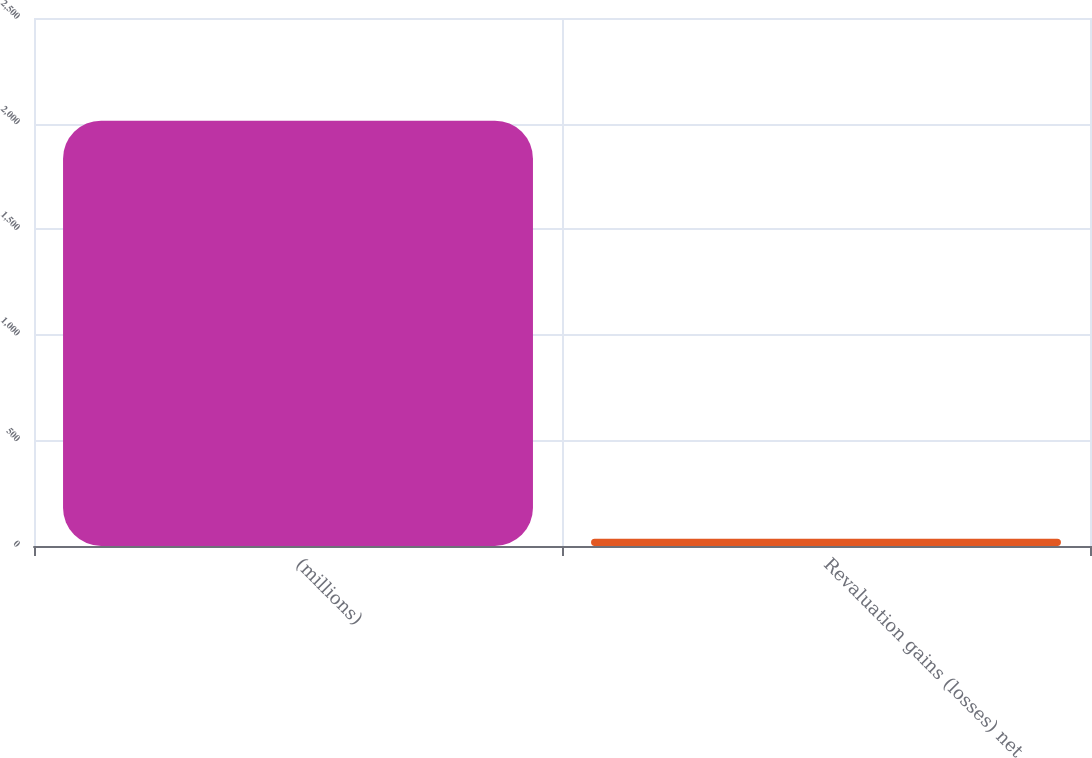Convert chart. <chart><loc_0><loc_0><loc_500><loc_500><bar_chart><fcel>(millions)<fcel>Revaluation gains (losses) net<nl><fcel>2014<fcel>34.7<nl></chart> 